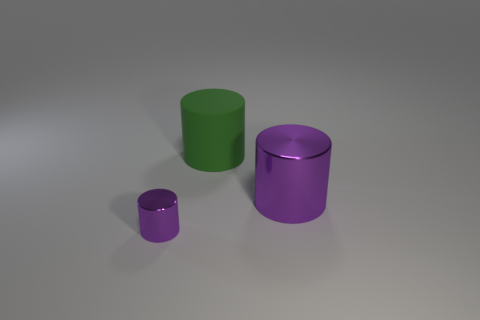What is the material of the other purple object that is the same shape as the tiny purple object?
Offer a very short reply. Metal. There is a large cylinder that is the same color as the tiny shiny object; what is its material?
Ensure brevity in your answer.  Metal. How many brown metallic things are the same shape as the big green rubber object?
Give a very brief answer. 0. Are there more green objects on the right side of the big purple cylinder than big matte cylinders that are left of the big rubber object?
Your answer should be compact. No. There is a big cylinder in front of the large rubber cylinder; does it have the same color as the big rubber cylinder?
Make the answer very short. No. What is the size of the matte thing?
Your answer should be compact. Large. There is a thing that is the same size as the green cylinder; what is it made of?
Offer a very short reply. Metal. What color is the tiny cylinder in front of the large matte object?
Ensure brevity in your answer.  Purple. How many large cylinders are there?
Your answer should be very brief. 2. Is there a purple object left of the big cylinder that is on the left side of the shiny thing behind the tiny shiny cylinder?
Your answer should be very brief. Yes. 